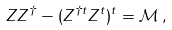Convert formula to latex. <formula><loc_0><loc_0><loc_500><loc_500>Z Z ^ { \dag } - ( Z ^ { \dag t } Z ^ { t } ) ^ { t } = \mathcal { M } \, ,</formula> 